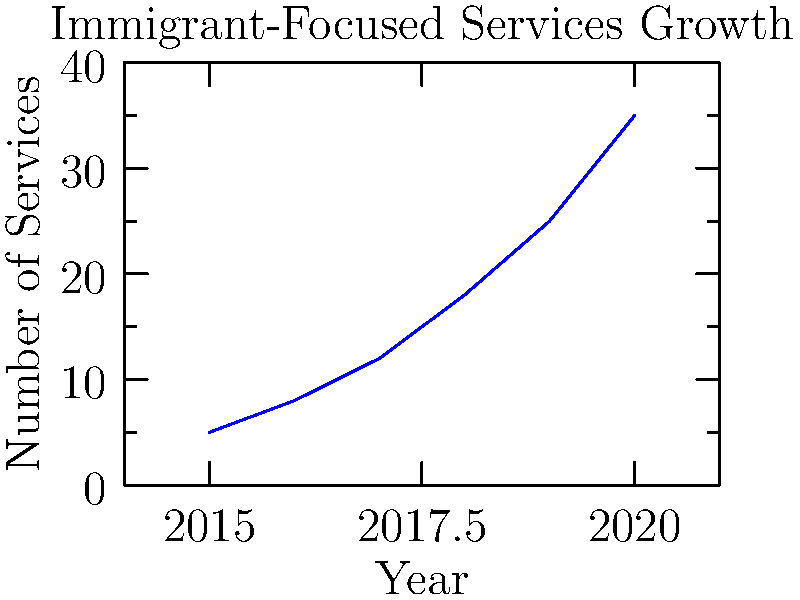Based on the line graph showing the growth of immigrant-focused services from 2015 to 2020, what was the average annual increase in the number of services provided? To calculate the average annual increase in immigrant-focused services:

1. Calculate the total increase:
   Services in 2020: 35
   Services in 2015: 5
   Total increase: 35 - 5 = 30 services

2. Determine the number of years:
   2020 - 2015 = 5 years

3. Calculate the average annual increase:
   Average annual increase = Total increase ÷ Number of years
   $\frac{30}{5} = 6$ services per year

Therefore, the average annual increase in immigrant-focused services was 6 services per year.
Answer: 6 services per year 